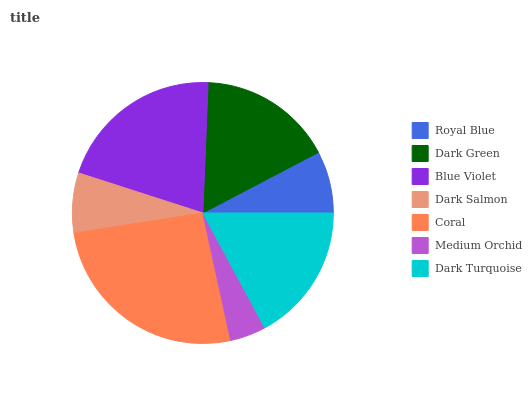Is Medium Orchid the minimum?
Answer yes or no. Yes. Is Coral the maximum?
Answer yes or no. Yes. Is Dark Green the minimum?
Answer yes or no. No. Is Dark Green the maximum?
Answer yes or no. No. Is Dark Green greater than Royal Blue?
Answer yes or no. Yes. Is Royal Blue less than Dark Green?
Answer yes or no. Yes. Is Royal Blue greater than Dark Green?
Answer yes or no. No. Is Dark Green less than Royal Blue?
Answer yes or no. No. Is Dark Green the high median?
Answer yes or no. Yes. Is Dark Green the low median?
Answer yes or no. Yes. Is Dark Turquoise the high median?
Answer yes or no. No. Is Royal Blue the low median?
Answer yes or no. No. 